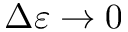Convert formula to latex. <formula><loc_0><loc_0><loc_500><loc_500>\Delta \varepsilon \to 0</formula> 